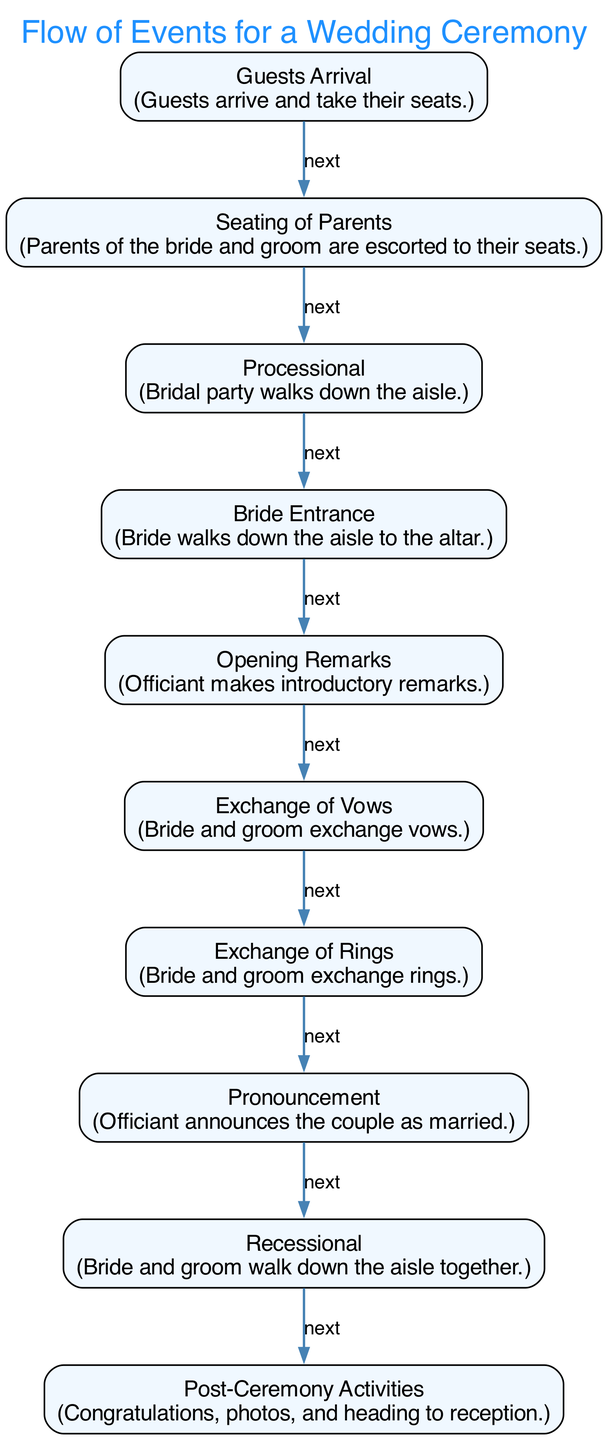What is the first event in the wedding ceremony flow? The first node in the diagram indicates the sequence of events. The text in the first node is "Guests Arrival," which means it is the starting point of the ceremony.
Answer: Guests Arrival How many nodes are there in the diagram? The number of nodes can be counted directly from the provided data. There are a total of 10 nodes listed that represent different events in the wedding ceremony.
Answer: 10 What is the last activity listed in the flow? Looking at the last node in the diagram, it describes "Post-Ceremony Activities," which is the final step of the event flow after the recessional.
Answer: Post-Ceremony Activities Which node follows the "Exchange of Vows"? By examining the edges, the "Exchange of Vows" node connects specifically to the "Exchange of Rings" node next in the sequence. Thus, that is the event that follows it.
Answer: Exchange of Rings What is the relationship between "Processional" and "Bride Entrance"? The "Processional" leads directly to the "Bride Entrance" as indicated by the connecting edge, showing that one event directly precedes the other in the flow of the ceremony.
Answer: next Which two nodes are connected by the relationship "next"? This phrase appears to connect each subsequent node in the event flow. For example, the node "Rings Exchange" is connected by "next" to "Pronouncement," indicating their sequential relationship.
Answer: Rings Exchange and Pronouncement What is the role of the officiant in the ceremony flow? The officiant's role is illustrated in the diagram through the "Opening Remarks" node, where the officiant makes introductory remarks, which is foundational for the subsequent events.
Answer: Opening Remarks How does the ceremony transition from the "Pronouncement" to the "Recessional"? The transition from "Pronouncement" to "Recessional" is marked by the edge stating "next," indicating a smooth flow from the officiant announcing the couple to them walking down the aisle together.
Answer: next What action is characterized in the "Bride Entrance" event? The description of the "Bride Entrance" specifically mentions that the bride walks down the aisle to the altar, marking a significant moment in the ceremony.
Answer: Bride walks down the aisle 